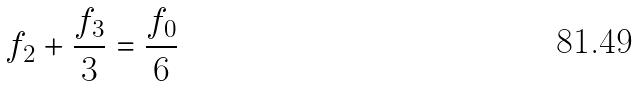Convert formula to latex. <formula><loc_0><loc_0><loc_500><loc_500>f _ { 2 } + \frac { f _ { 3 } } { 3 } = \frac { f _ { 0 } } { 6 }</formula> 